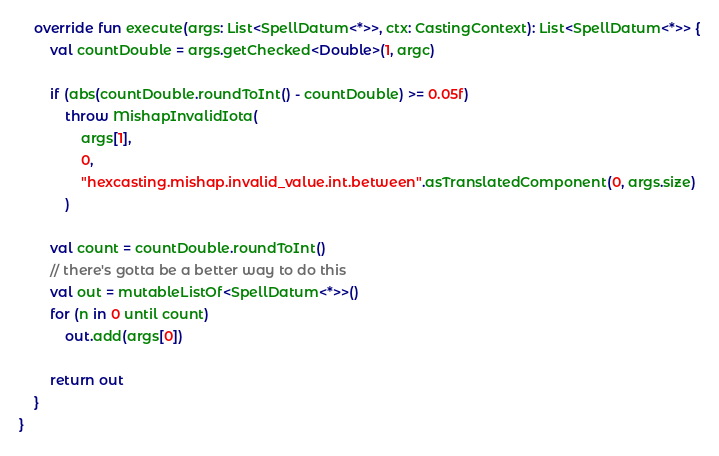Convert code to text. <code><loc_0><loc_0><loc_500><loc_500><_Kotlin_>
    override fun execute(args: List<SpellDatum<*>>, ctx: CastingContext): List<SpellDatum<*>> {
        val countDouble = args.getChecked<Double>(1, argc)

        if (abs(countDouble.roundToInt() - countDouble) >= 0.05f)
            throw MishapInvalidIota(
                args[1],
                0,
                "hexcasting.mishap.invalid_value.int.between".asTranslatedComponent(0, args.size)
            )

        val count = countDouble.roundToInt()
        // there's gotta be a better way to do this
        val out = mutableListOf<SpellDatum<*>>()
        for (n in 0 until count)
            out.add(args[0])

        return out
    }
}
</code> 